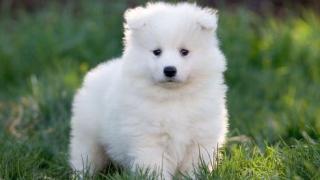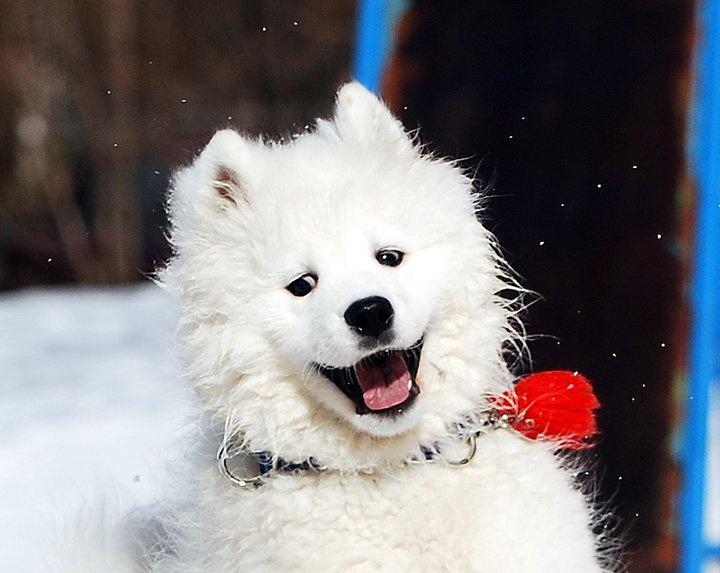The first image is the image on the left, the second image is the image on the right. For the images displayed, is the sentence "We have no more than three dogs in total." factually correct? Answer yes or no. Yes. The first image is the image on the left, the second image is the image on the right. Evaluate the accuracy of this statement regarding the images: "There are no more than three dogs and one of them has it's mouth open.". Is it true? Answer yes or no. Yes. 